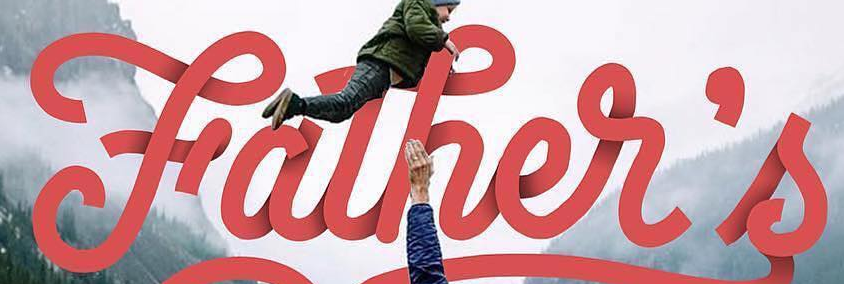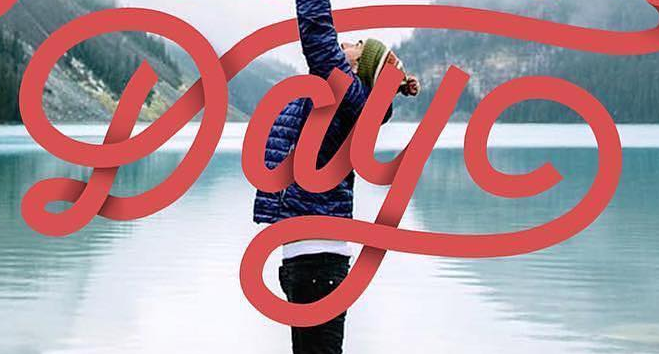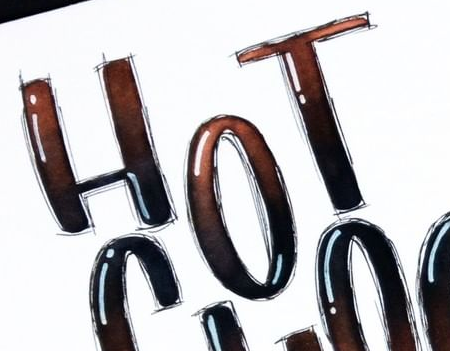Read the text content from these images in order, separated by a semicolon. Father's; Day; HOT 